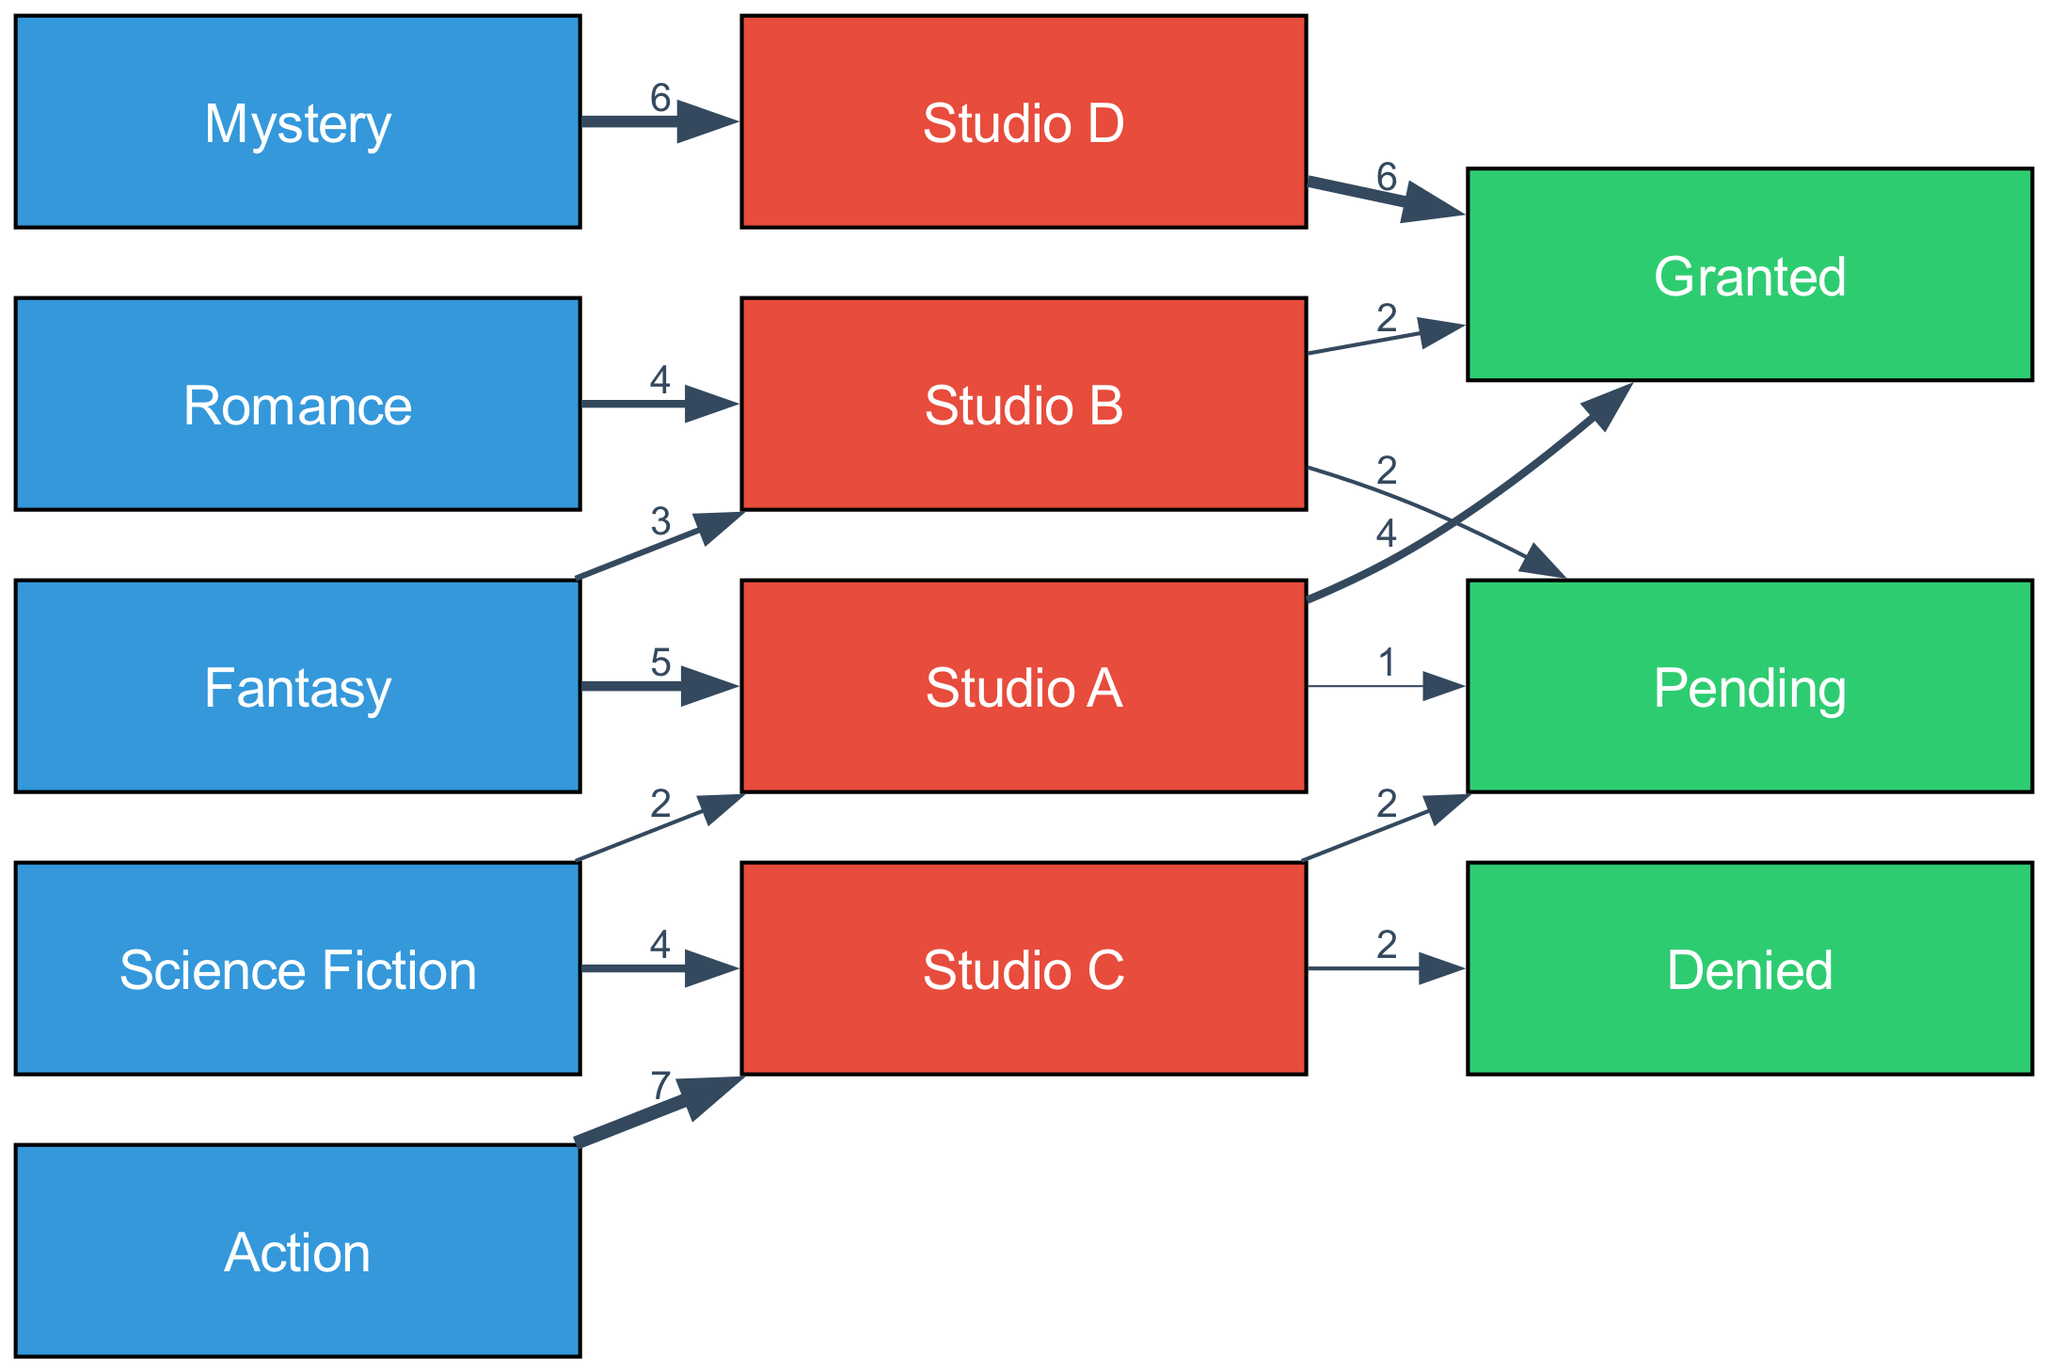What is the total number of adaptation requests for Fantasy? To find the total number of adaptation requests for the Fantasy genre, I will add the values linked to the Fantasy node: Studio A has 5 requests, and Studio B has 3 requests. Therefore, 5 + 3 equals 8.
Answer: 8 Which studio has the highest number of granted outcomes? I will examine the links from each studio to the Granted outcome. Studio D has 6 granted requests, while Studio A has 4, and Studio B has 2. Since 6 is greater than the others, Studio D has the highest.
Answer: Studio D How many adaptation requests were denied in total? To answer this, I will look at the links leading to the Denied outcome. Studio C has 2 denied requests. Since that's the only entry, the total is 2.
Answer: 2 Which genre has the most requests to Studio C? I need to review the links from different genres to Studio C. The Action genre has 7 requests, while Science Fiction has 2. Thus, Action has the most requests to Studio C.
Answer: Action What is the total number of pending outcomes from Studio B? I'll check the links from Studio B to the Pending outcome. Studio B has 2 requests that are Pending. Thus, the total is simply 2.
Answer: 2 How many more granted outcomes than denied outcomes are there overall? First, I will calculate the total granted outcomes: Studio A has 4, Studio B has 2, and Studio D has 6. This totals 12 granted outcomes. For denied outcomes, Studio C has 2, giving a total of 2 denied. The difference is calculated by subtracting 2 from 12, resulting in 10.
Answer: 10 What percentage of requests for Romance were granted? To determine this, I will find the total number of requests for Romance, which is 4 (all from Studio B). Out of these, 2 were granted. To compute the percentage, I will divide 2 by 4 and multiply by 100, resulting in 50 percent.
Answer: 50 percent Which genre has the least overall requests? I will sum the number of requests for each genre based on the links. Fantasy has 8, Science Fiction has 6, Mystery has 6, Romance has 4, and Action has 7. Romance has the least with 4 requests.
Answer: Romance 